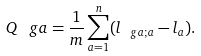Convert formula to latex. <formula><loc_0><loc_0><loc_500><loc_500>Q _ { \ } g a = \frac { 1 } { m } \sum _ { a = 1 } ^ { n } ( l _ { \ g a ; a } - l _ { a } ) .</formula> 